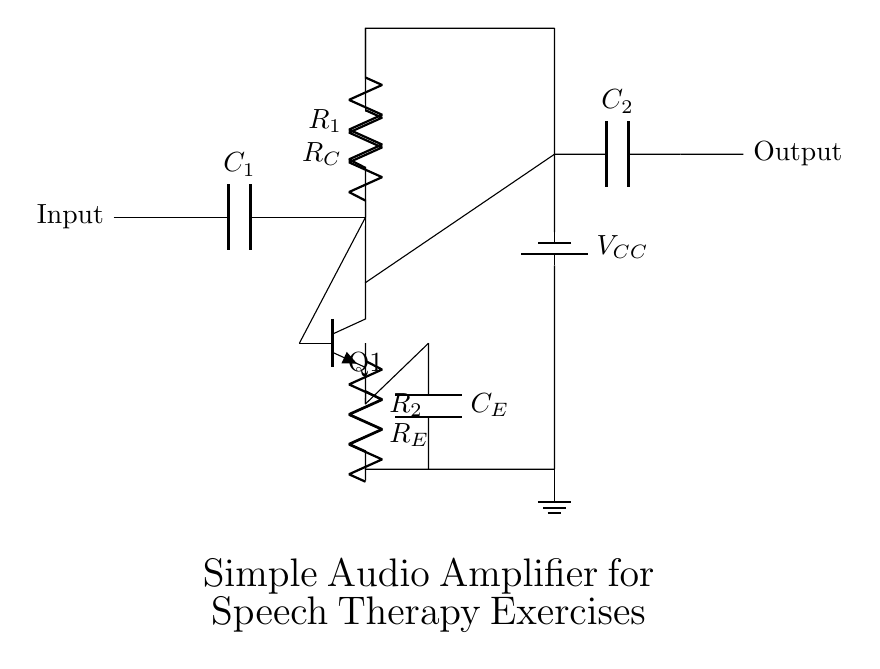What is the function of C1 in the circuit? C1 is a coupling capacitor that allows AC signals (like sound) to pass through while blocking any DC component. This is important for amplifying speech signals without interference from DC voltage.
Answer: Coupling capacitor What type of transistor is used in this amplifier? The circuit diagram indicates that an NPN transistor is used, as shown by the symbol for Q1. NPN transistors are commonly utilized for amplification purposes.
Answer: NPN What does R_E do in the circuit? R_E is the emitter resistor, which helps stabilize the transistor's operation. It improves linearity and prevents distortion in the amplified output, making it essential for audio applications.
Answer: Emitter resistor What is the role of C2 in the circuit? C2 serves as a coupling capacitor for the output, allowing the amplified audio signal to pass to the next stage or speaker while preventing DC voltage from being transferred. This ensures only the audio signal is outputted.
Answer: Coupling capacitor Which component provides power to the amplifier? The power supply is provided by V_CC, which is the voltage source connected to the circuit. It powers the transistor by providing the necessary voltage for amplification.
Answer: Voltage source What happens if R_C is too high? If R_C (the collector resistor) is too high, it can limit the current flowing through the transistor, resulting in reduced gain and potential distortion of the output signal. Therefore, careful selection of R_C is crucial for desired performance.
Answer: Reduced gain 